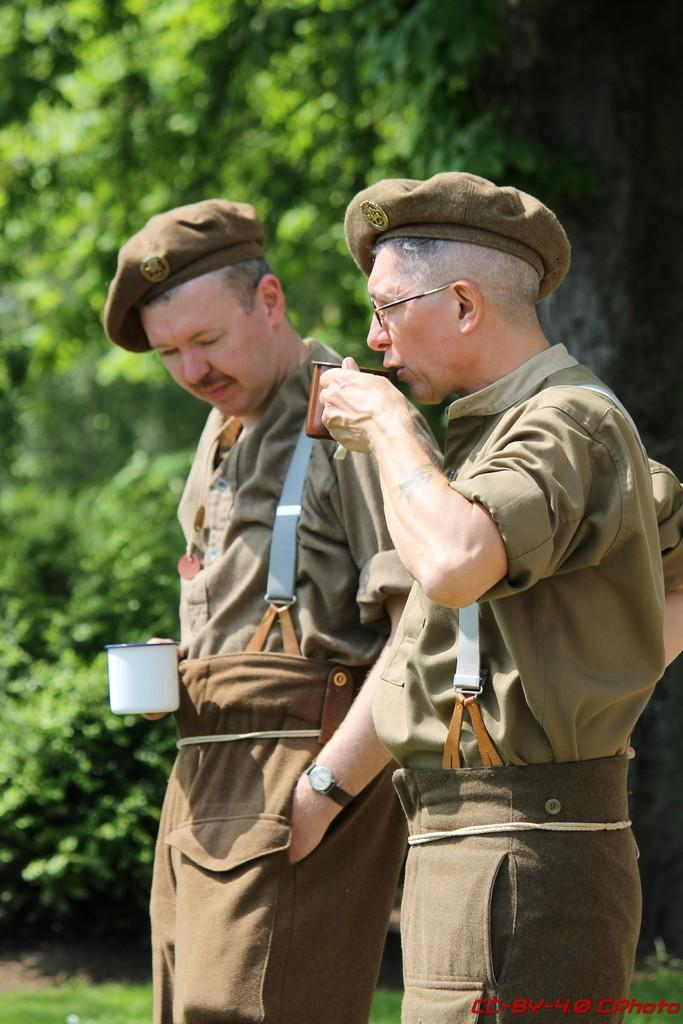What are the people in the image doing? The persons in the image are standing in the front and holding cups in their hands. Can you describe the background of the image? There are trees in the background of the image. How many people can be seen in the image? There is at least one man standing in the front of the image. What is the man doing in the image? The man is drinking from a cup. What type of guitar is the lawyer playing in the image? There is no lawyer or guitar present in the image. How many crows can be seen sitting on the trees in the image? There are no crows visible in the image; only trees are present in the background. 